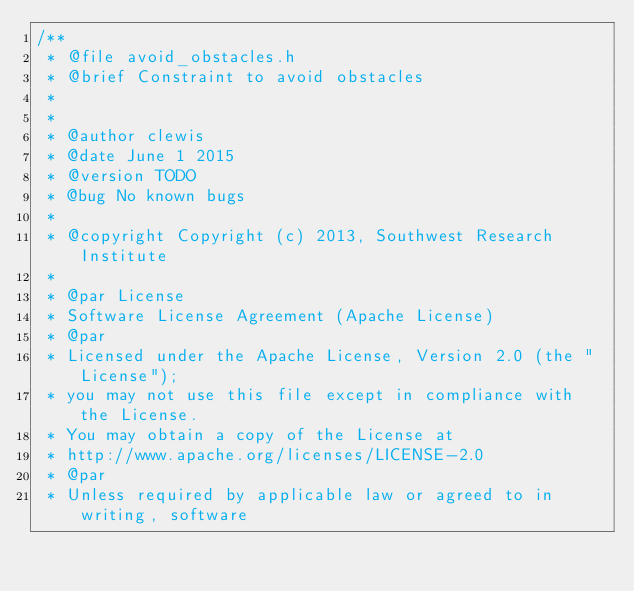Convert code to text. <code><loc_0><loc_0><loc_500><loc_500><_C_>/**
 * @file avoid_obstacles.h
 * @brief Constraint to avoid obstacles
 *
 *
 * @author clewis
 * @date June 1 2015
 * @version TODO
 * @bug No known bugs
 *
 * @copyright Copyright (c) 2013, Southwest Research Institute
 *
 * @par License
 * Software License Agreement (Apache License)
 * @par
 * Licensed under the Apache License, Version 2.0 (the "License");
 * you may not use this file except in compliance with the License.
 * You may obtain a copy of the License at
 * http://www.apache.org/licenses/LICENSE-2.0
 * @par
 * Unless required by applicable law or agreed to in writing, software</code> 